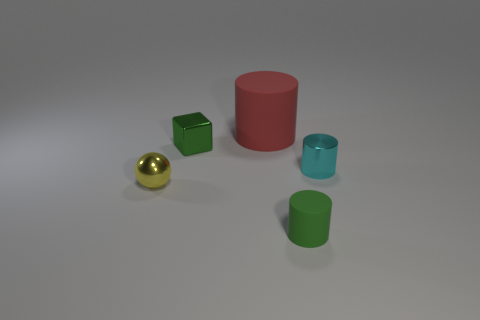Add 1 green matte cylinders. How many objects exist? 6 Subtract all blocks. How many objects are left? 4 Add 3 tiny yellow things. How many tiny yellow things exist? 4 Subtract 1 green cylinders. How many objects are left? 4 Subtract all large red cylinders. Subtract all small green things. How many objects are left? 2 Add 5 red things. How many red things are left? 6 